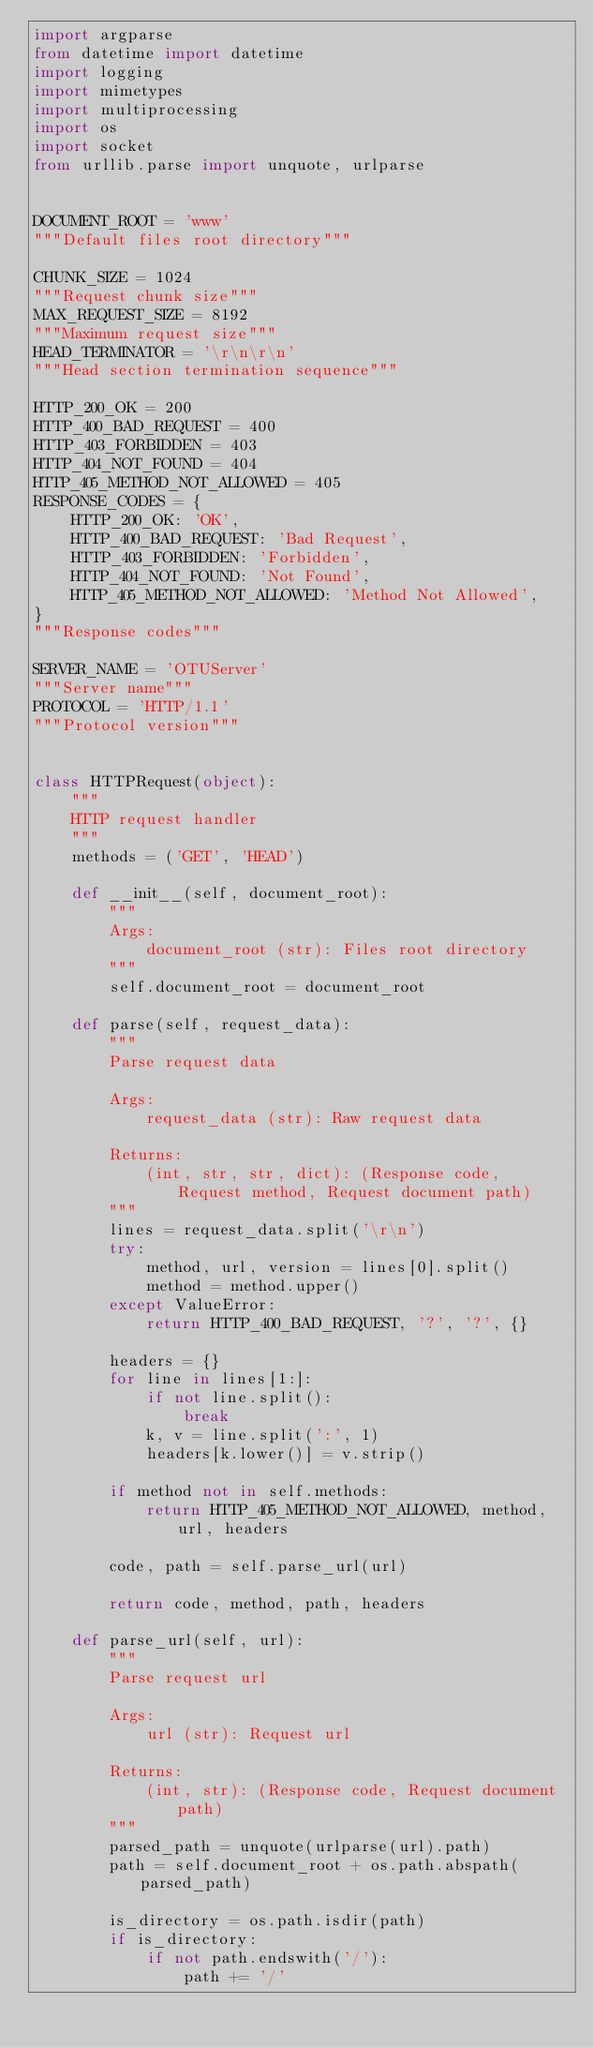<code> <loc_0><loc_0><loc_500><loc_500><_Python_>import argparse
from datetime import datetime
import logging
import mimetypes
import multiprocessing
import os
import socket
from urllib.parse import unquote, urlparse


DOCUMENT_ROOT = 'www'
"""Default files root directory"""

CHUNK_SIZE = 1024
"""Request chunk size"""
MAX_REQUEST_SIZE = 8192
"""Maximum request size"""
HEAD_TERMINATOR = '\r\n\r\n'
"""Head section termination sequence"""

HTTP_200_OK = 200
HTTP_400_BAD_REQUEST = 400
HTTP_403_FORBIDDEN = 403
HTTP_404_NOT_FOUND = 404
HTTP_405_METHOD_NOT_ALLOWED = 405
RESPONSE_CODES = {
    HTTP_200_OK: 'OK',
    HTTP_400_BAD_REQUEST: 'Bad Request',
    HTTP_403_FORBIDDEN: 'Forbidden',
    HTTP_404_NOT_FOUND: 'Not Found',
    HTTP_405_METHOD_NOT_ALLOWED: 'Method Not Allowed',
}
"""Response codes"""

SERVER_NAME = 'OTUServer'
"""Server name"""
PROTOCOL = 'HTTP/1.1'
"""Protocol version"""


class HTTPRequest(object):
    """
    HTTP request handler
    """
    methods = ('GET', 'HEAD')

    def __init__(self, document_root):
        """
        Args:
            document_root (str): Files root directory
        """
        self.document_root = document_root

    def parse(self, request_data):
        """
        Parse request data

        Args:
            request_data (str): Raw request data

        Returns:
            (int, str, str, dict): (Response code, Request method, Request document path)
        """
        lines = request_data.split('\r\n')
        try:
            method, url, version = lines[0].split()
            method = method.upper()
        except ValueError:
            return HTTP_400_BAD_REQUEST, '?', '?', {}

        headers = {}
        for line in lines[1:]:
            if not line.split():
                break
            k, v = line.split(':', 1)
            headers[k.lower()] = v.strip()

        if method not in self.methods:
            return HTTP_405_METHOD_NOT_ALLOWED, method, url, headers

        code, path = self.parse_url(url)

        return code, method, path, headers

    def parse_url(self, url):
        """
        Parse request url

        Args:
            url (str): Request url

        Returns:
            (int, str): (Response code, Request document path)
        """
        parsed_path = unquote(urlparse(url).path)
        path = self.document_root + os.path.abspath(parsed_path)

        is_directory = os.path.isdir(path)
        if is_directory:
            if not path.endswith('/'):
                path += '/'</code> 